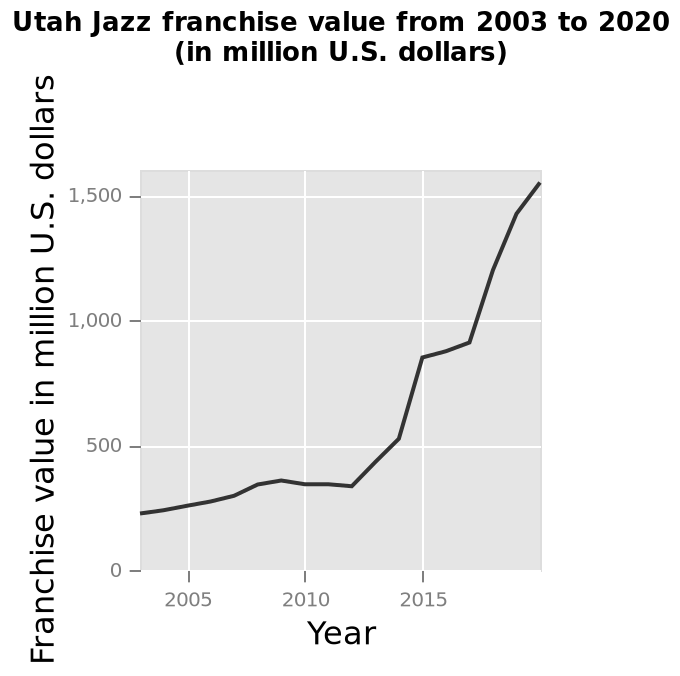<image>
please enumerates aspects of the construction of the chart Utah Jazz franchise value from 2003 to 2020 (in million U.S. dollars) is a line plot. A linear scale with a minimum of 2005 and a maximum of 2015 can be seen along the x-axis, labeled Year. The y-axis measures Franchise value in million U.S. dollars. What was the annual increase in the franchise value until 2012?  The franchise value had a gradual increase of approximately 40 dollars per year until 2012. 